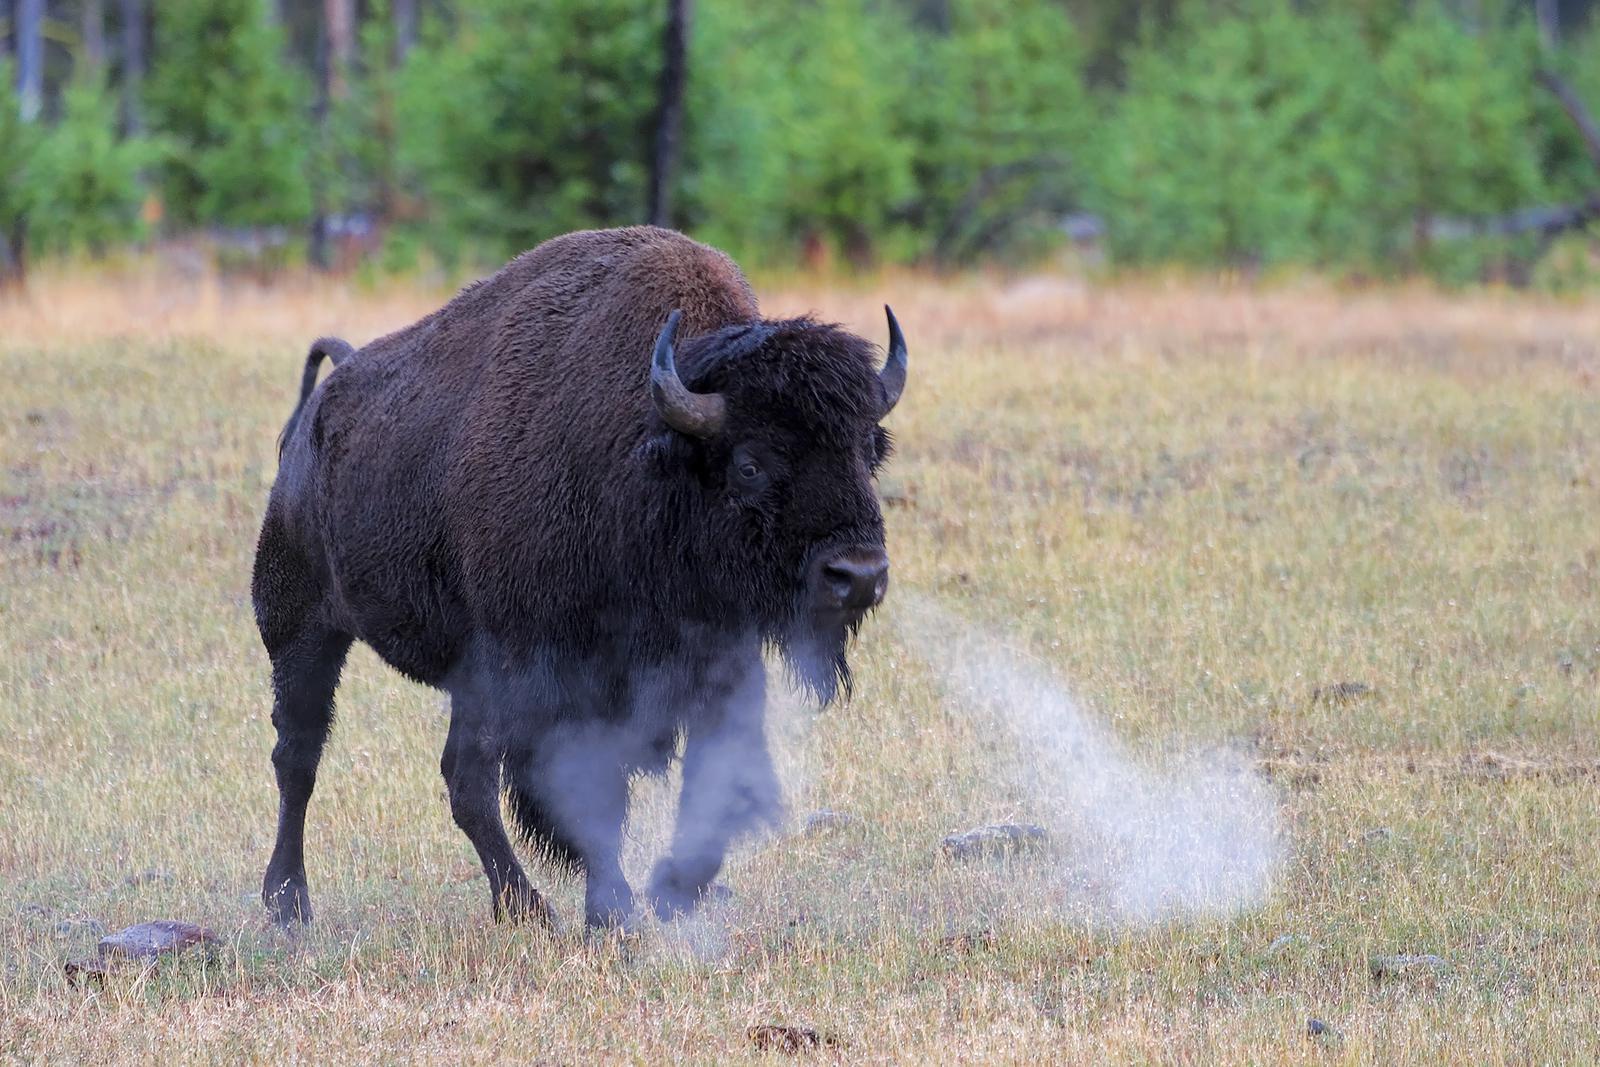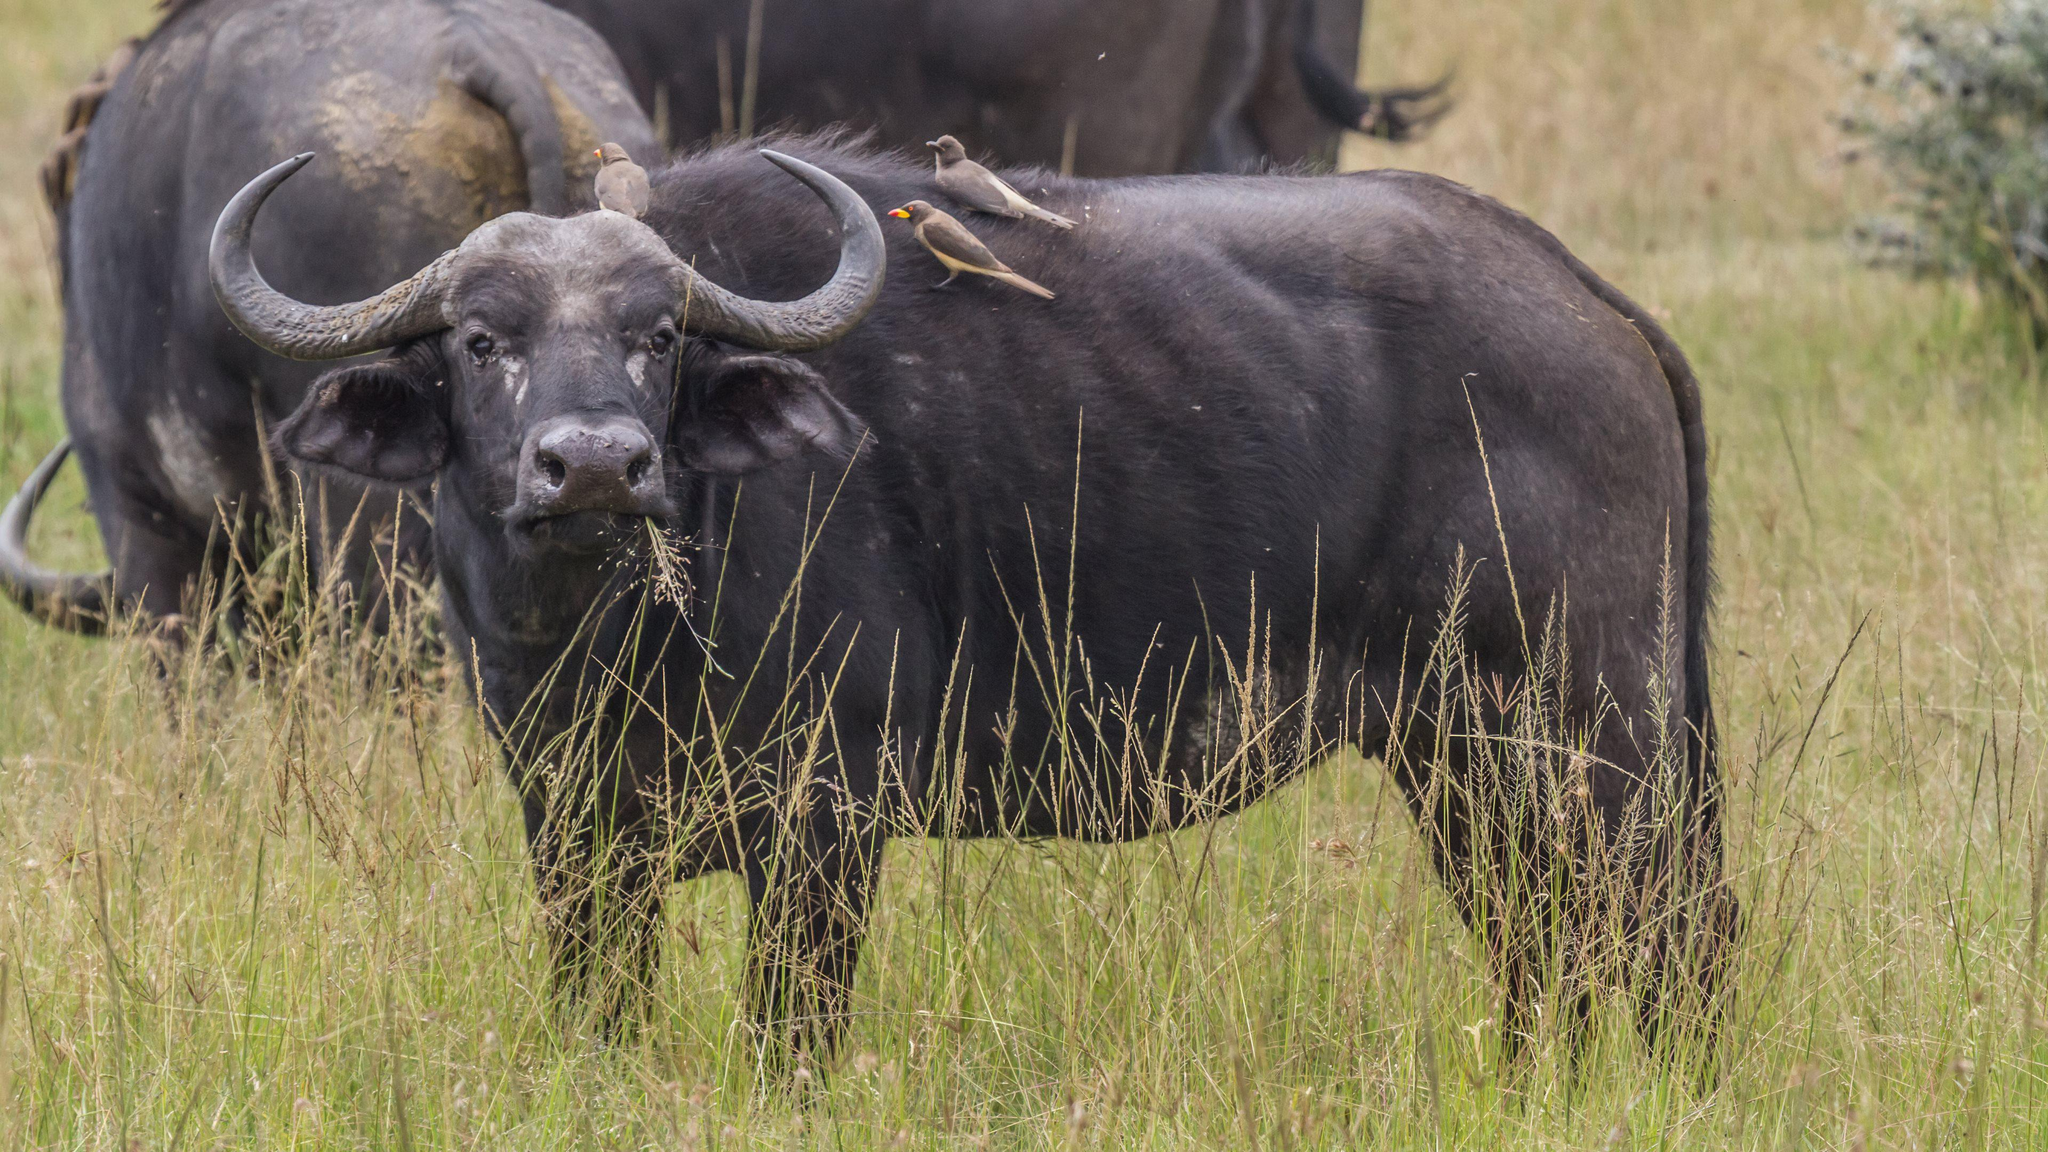The first image is the image on the left, the second image is the image on the right. Given the left and right images, does the statement "There are at least two water buffalo's in the right image." hold true? Answer yes or no. Yes. 